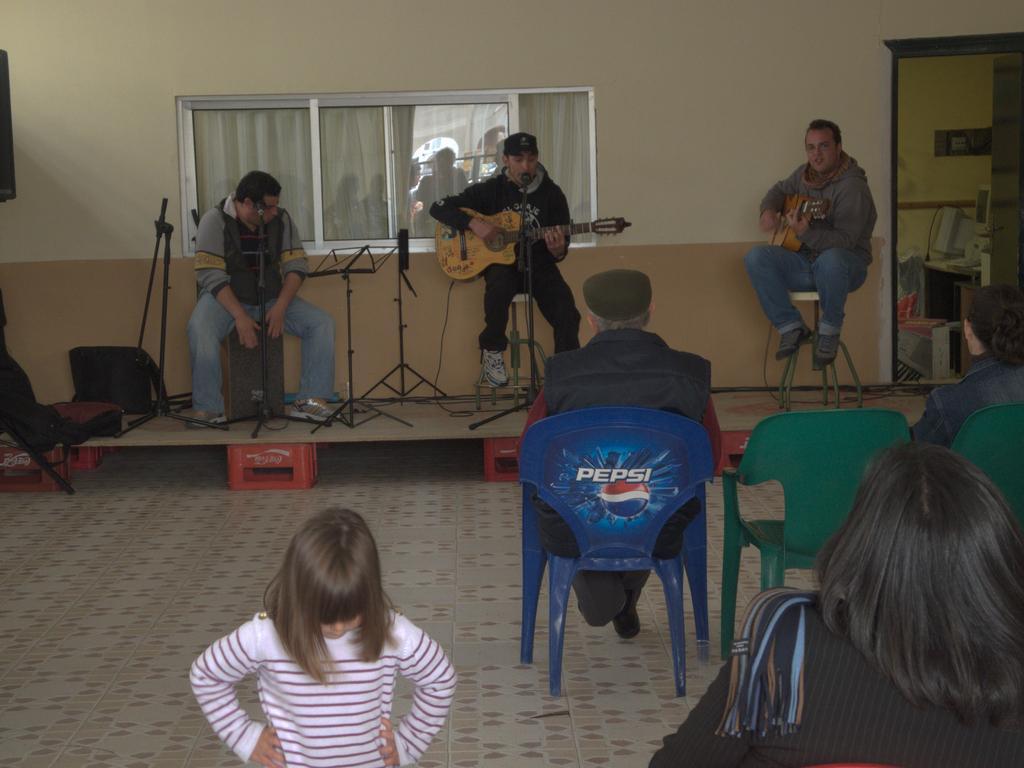Please provide a concise description of this image. In this picture we can see three men sitting on stool on stage and her two persons are holding guitar in their hands and playing and in middle person singing on mic and in front of them we can see some people sitting on chairs and here girl standing on floor in background we can see wall, window. 